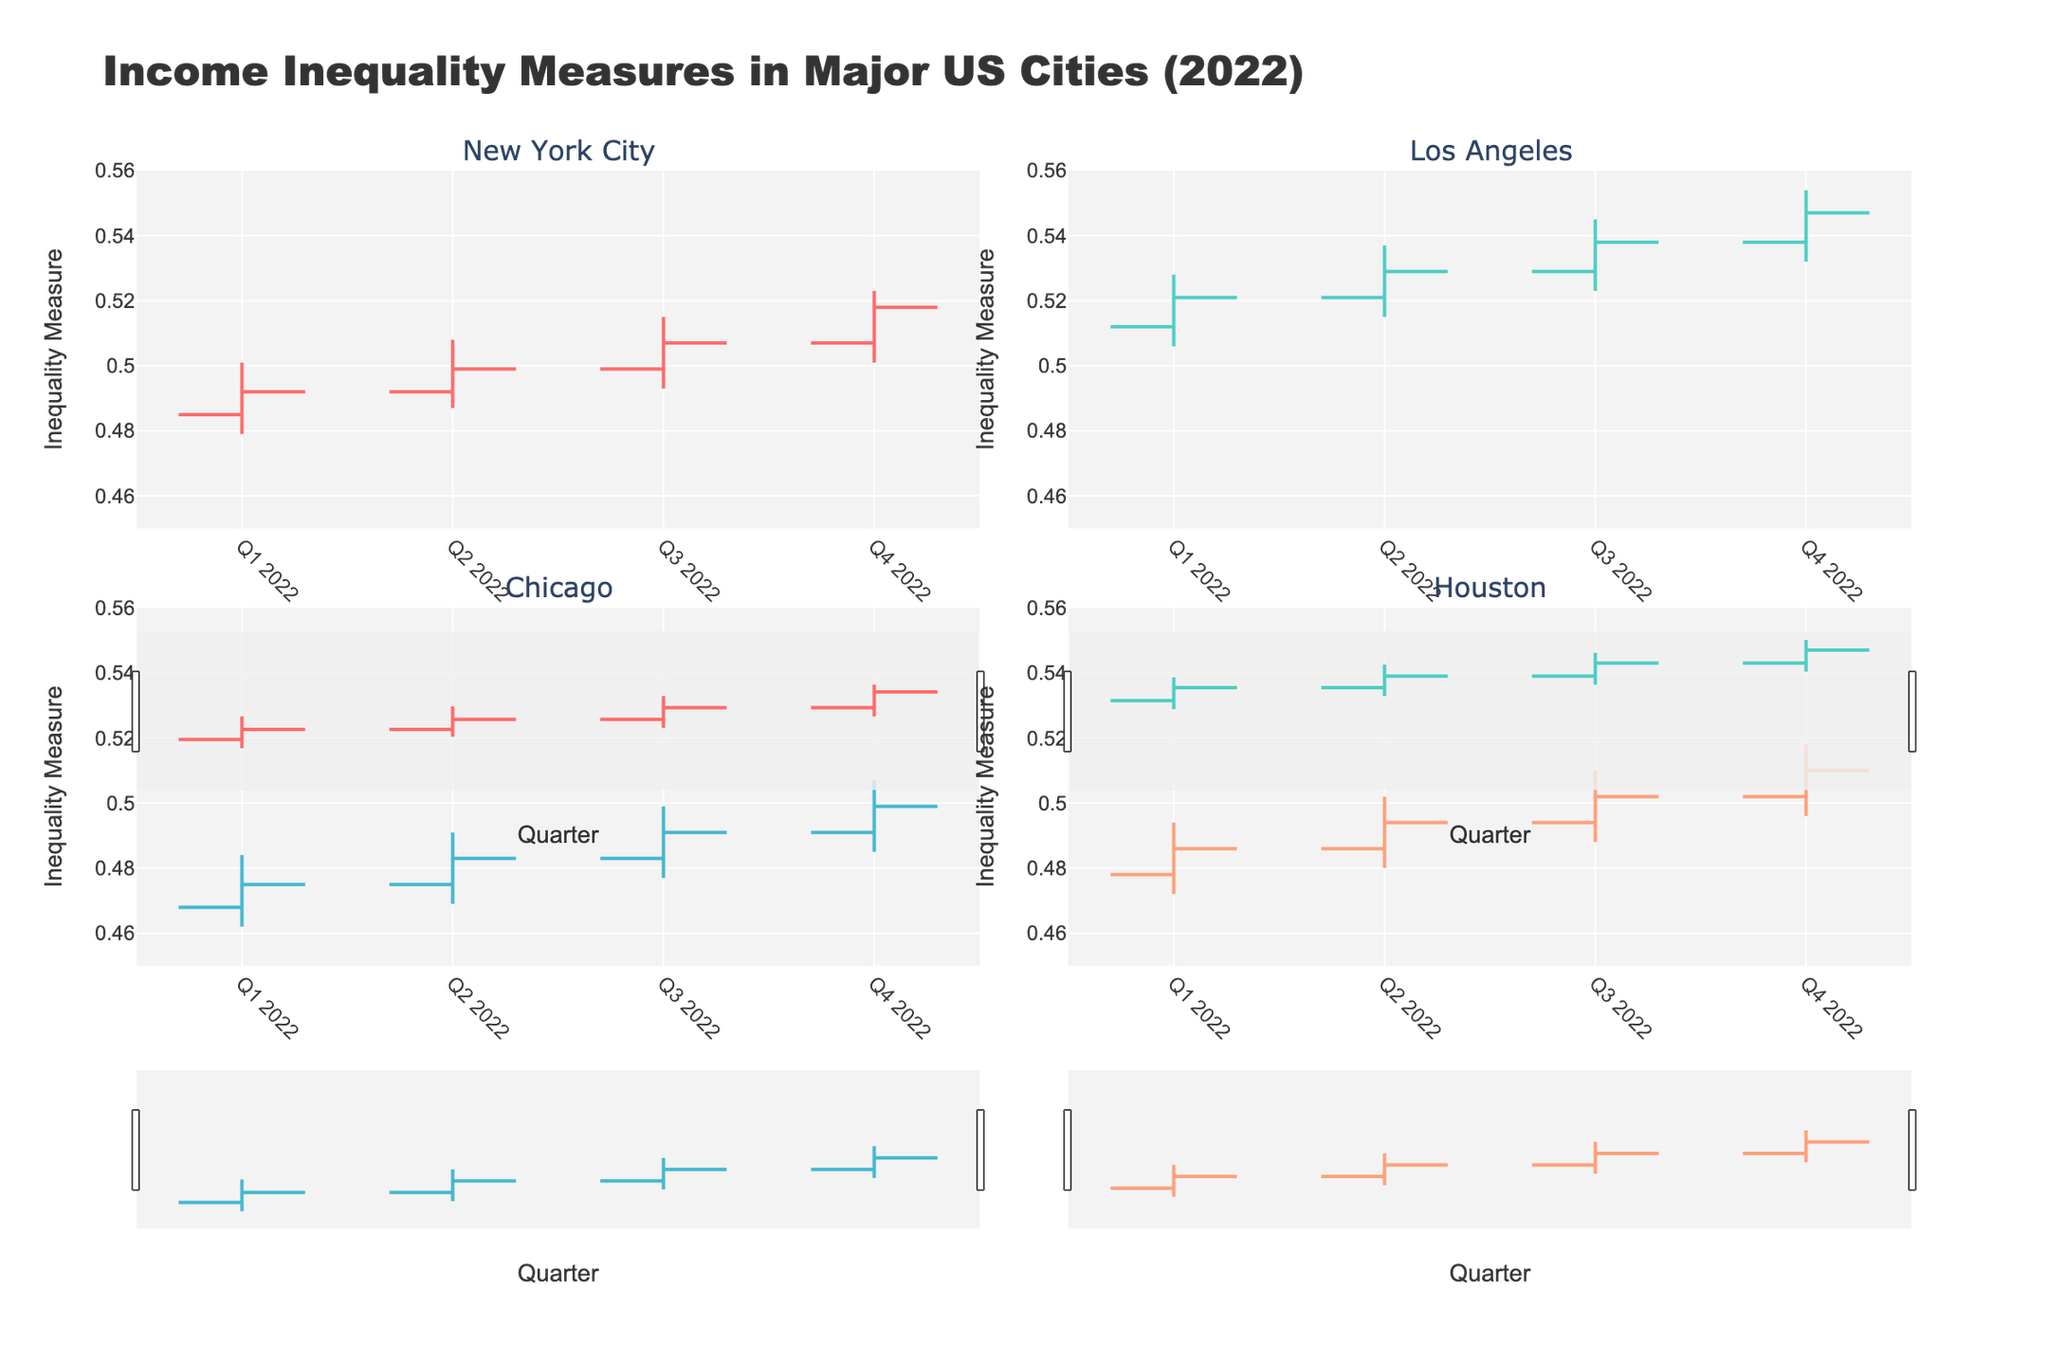What's the title of the figure? Look at the top of the plot where the title is usually displayed. The title should provide an overall description of the data presented in the figure.
Answer: Income Inequality Measures in Major US Cities (2022) Which city has the highest 'Close' value in Q4 2022? For this, locate Q4 2022 for each city in the figure, and then find the 'Close' value. Compare the values to determine the highest.
Answer: Los Angeles What is the range of values displayed on the y-axis? Observe the y-axis for any indications of minimum and maximum values that it spans.
Answer: 0.45 to 0.56 Which city shows the most consistent increase in the inequality measure throughout 2022? Identify the general trend for each city's inequality measure over the four quarters by examining each subplot in the figure. Consistency in increase implies a general upward trend without erratic dips.
Answer: New York City How does Chicago's Q2 2022 'Close' value compare to New York City's Q3 2022 'Open' value? Locate the Q2 2022 'Close' value for Chicago and then the Q3 2022 'Open' value for New York City. Compare the two values to see which is higher or if they are equal.
Answer: Chicago's Q2 2022 'Close' value is lower Which quarter shows the highest 'High' value for Houston? Find the maximum 'High' value for Houston across all four quarters by examining each point where the 'High' value is indicated.
Answer: Q4 2022 Which city had the largest increase in the 'Close' value from Q1 2022 to Q4 2022? Calculate the difference between Q4 2022 'Close' value and Q1 2022 'Close' value for each city, then identify the city with the largest positive difference.
Answer: Los Angeles What is the difference between the 'Low' and 'High' values for New York City in Q3 2022? Locate the 'Low' and 'High' values for New York City in Q3 2022 and subtract the 'Low' value from the 'High' value for the difference.
Answer: 0.022 Does any city show a decreasing trend in inequality measures in any quarter of 2022? Examine each subplot to see if the 'Close' value for any city in any quarter is less than its 'Open' value for that same quarter. A decrease would reflect a downturn in the specified quarter.
Answer: No What are the 'Open' and 'Close' values for Los Angeles in Q2 2022, and how does the 'Close' compare to the 'Open'? Find the 'Open' and 'Close' values for Los Angeles in Q2 2022. Compare by noting if the 'Close' value is higher, lower, or equal to the 'Open' value.
Answer: 'Open': 0.521, 'Close': 0.529, 'Close' is higher 